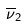Convert formula to latex. <formula><loc_0><loc_0><loc_500><loc_500>\overline { \nu } _ { 2 }</formula> 